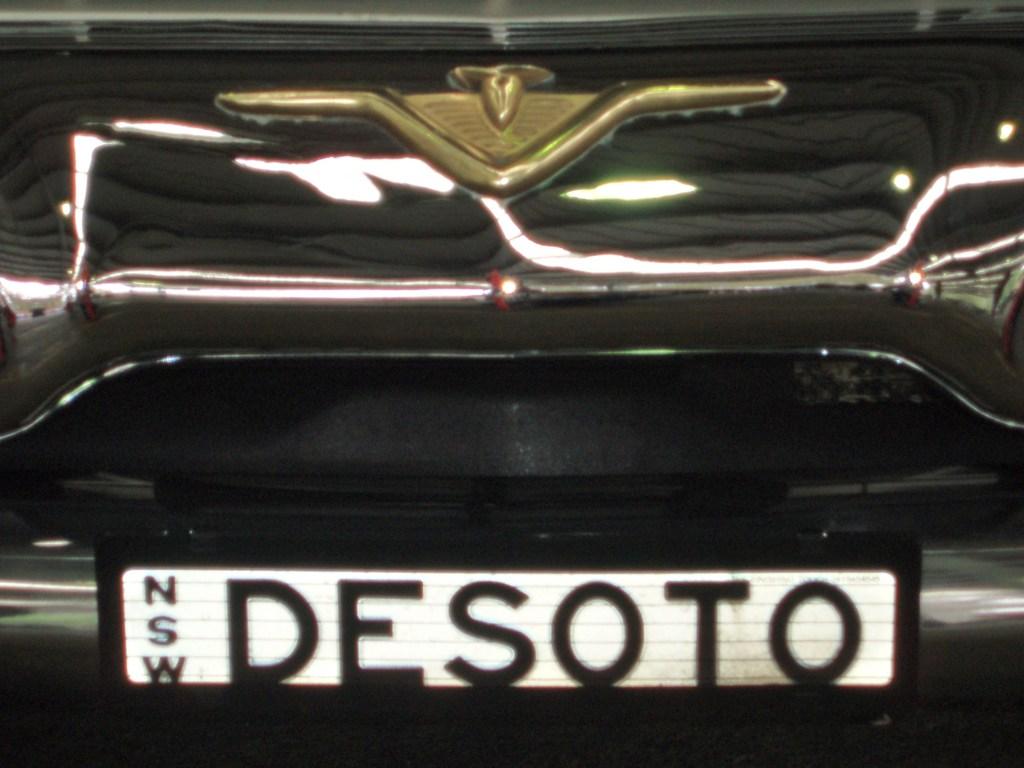What does the license plate say?
Make the answer very short. Desoto. What does the sign say?
Make the answer very short. Nsw desoto. 